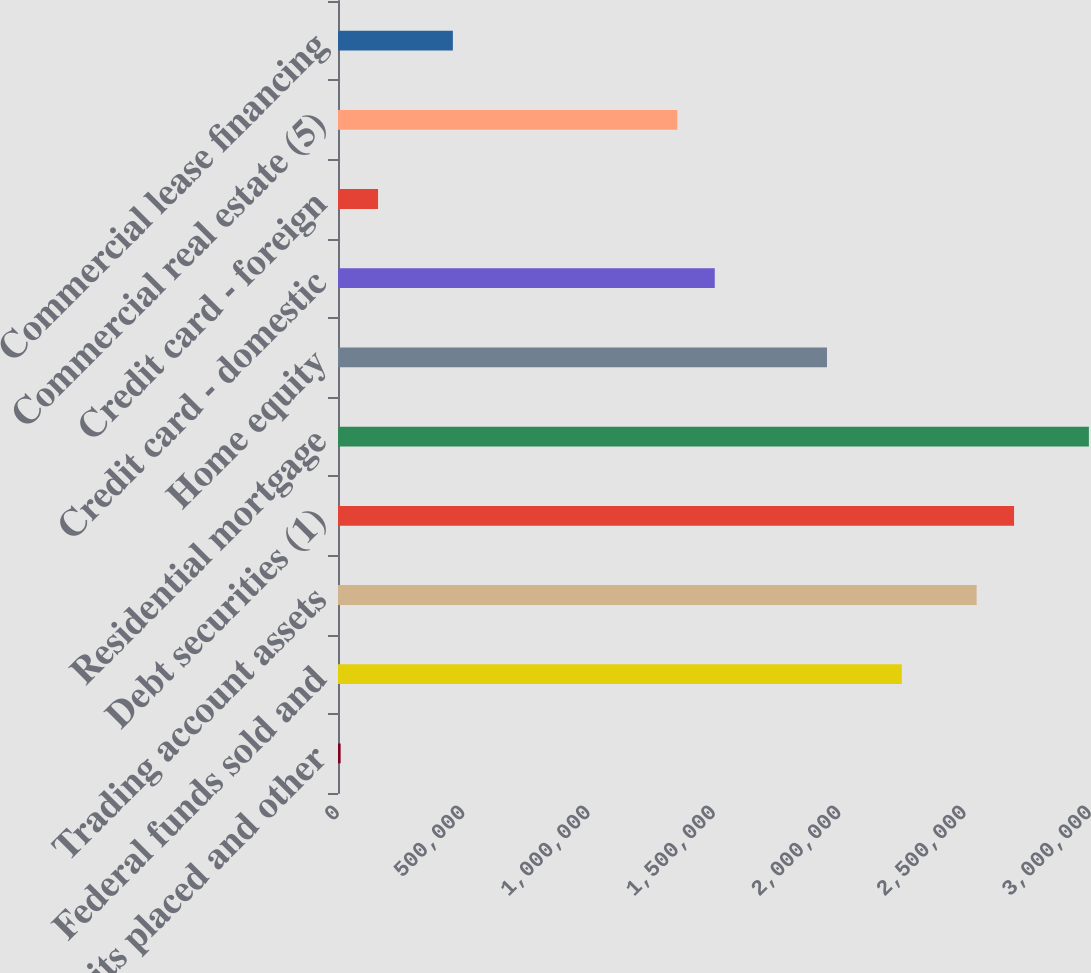Convert chart. <chart><loc_0><loc_0><loc_500><loc_500><bar_chart><fcel>Time deposits placed and other<fcel>Federal funds sold and<fcel>Trading account assets<fcel>Debt securities (1)<fcel>Residential mortgage<fcel>Home equity<fcel>Credit card - domestic<fcel>Credit card - foreign<fcel>Commercial real estate (5)<fcel>Commercial lease financing<nl><fcel>10459<fcel>2.24927e+06<fcel>2.54778e+06<fcel>2.69703e+06<fcel>2.99554e+06<fcel>1.95076e+06<fcel>1.503e+06<fcel>159713<fcel>1.35374e+06<fcel>458221<nl></chart> 